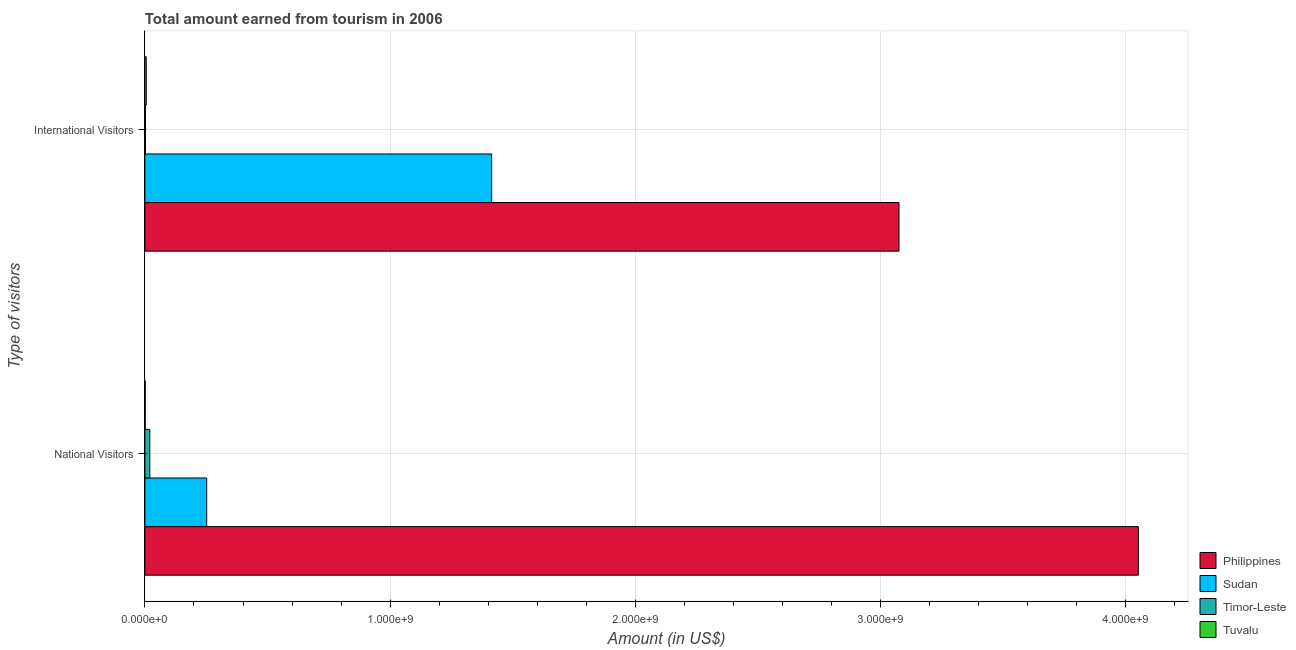How many different coloured bars are there?
Keep it short and to the point. 4. How many groups of bars are there?
Give a very brief answer. 2. Are the number of bars on each tick of the Y-axis equal?
Your answer should be compact. Yes. How many bars are there on the 2nd tick from the top?
Provide a short and direct response. 4. How many bars are there on the 1st tick from the bottom?
Offer a terse response. 4. What is the label of the 2nd group of bars from the top?
Your answer should be very brief. National Visitors. What is the amount earned from international visitors in Timor-Leste?
Give a very brief answer. 2.30e+06. Across all countries, what is the maximum amount earned from international visitors?
Provide a short and direct response. 3.08e+09. Across all countries, what is the minimum amount earned from national visitors?
Your response must be concise. 1.18e+06. In which country was the amount earned from international visitors minimum?
Give a very brief answer. Timor-Leste. What is the total amount earned from national visitors in the graph?
Provide a short and direct response. 4.32e+09. What is the difference between the amount earned from national visitors in Timor-Leste and that in Tuvalu?
Offer a terse response. 1.88e+07. What is the difference between the amount earned from national visitors in Timor-Leste and the amount earned from international visitors in Philippines?
Your answer should be compact. -3.06e+09. What is the average amount earned from international visitors per country?
Provide a short and direct response. 1.12e+09. What is the difference between the amount earned from international visitors and amount earned from national visitors in Tuvalu?
Offer a very short reply. 4.25e+06. What is the ratio of the amount earned from international visitors in Timor-Leste to that in Tuvalu?
Ensure brevity in your answer.  0.42. In how many countries, is the amount earned from international visitors greater than the average amount earned from international visitors taken over all countries?
Offer a very short reply. 2. What does the 4th bar from the top in National Visitors represents?
Provide a short and direct response. Philippines. What does the 2nd bar from the bottom in National Visitors represents?
Offer a terse response. Sudan. How many bars are there?
Keep it short and to the point. 8. How many countries are there in the graph?
Provide a short and direct response. 4. Are the values on the major ticks of X-axis written in scientific E-notation?
Ensure brevity in your answer.  Yes. Does the graph contain grids?
Ensure brevity in your answer.  Yes. Where does the legend appear in the graph?
Your response must be concise. Bottom right. What is the title of the graph?
Keep it short and to the point. Total amount earned from tourism in 2006. Does "Algeria" appear as one of the legend labels in the graph?
Offer a very short reply. No. What is the label or title of the X-axis?
Offer a very short reply. Amount (in US$). What is the label or title of the Y-axis?
Your answer should be compact. Type of visitors. What is the Amount (in US$) in Philippines in National Visitors?
Your answer should be very brief. 4.05e+09. What is the Amount (in US$) in Sudan in National Visitors?
Your answer should be compact. 2.52e+08. What is the Amount (in US$) in Tuvalu in National Visitors?
Offer a terse response. 1.18e+06. What is the Amount (in US$) in Philippines in International Visitors?
Offer a terse response. 3.08e+09. What is the Amount (in US$) of Sudan in International Visitors?
Make the answer very short. 1.41e+09. What is the Amount (in US$) in Timor-Leste in International Visitors?
Your answer should be very brief. 2.30e+06. What is the Amount (in US$) in Tuvalu in International Visitors?
Provide a succinct answer. 5.43e+06. Across all Type of visitors, what is the maximum Amount (in US$) of Philippines?
Give a very brief answer. 4.05e+09. Across all Type of visitors, what is the maximum Amount (in US$) in Sudan?
Offer a very short reply. 1.41e+09. Across all Type of visitors, what is the maximum Amount (in US$) of Timor-Leste?
Keep it short and to the point. 2.00e+07. Across all Type of visitors, what is the maximum Amount (in US$) of Tuvalu?
Ensure brevity in your answer.  5.43e+06. Across all Type of visitors, what is the minimum Amount (in US$) of Philippines?
Provide a succinct answer. 3.08e+09. Across all Type of visitors, what is the minimum Amount (in US$) of Sudan?
Your answer should be compact. 2.52e+08. Across all Type of visitors, what is the minimum Amount (in US$) in Timor-Leste?
Keep it short and to the point. 2.30e+06. Across all Type of visitors, what is the minimum Amount (in US$) of Tuvalu?
Keep it short and to the point. 1.18e+06. What is the total Amount (in US$) in Philippines in the graph?
Offer a terse response. 7.13e+09. What is the total Amount (in US$) of Sudan in the graph?
Offer a very short reply. 1.67e+09. What is the total Amount (in US$) in Timor-Leste in the graph?
Your answer should be compact. 2.23e+07. What is the total Amount (in US$) of Tuvalu in the graph?
Give a very brief answer. 6.61e+06. What is the difference between the Amount (in US$) of Philippines in National Visitors and that in International Visitors?
Ensure brevity in your answer.  9.76e+08. What is the difference between the Amount (in US$) in Sudan in National Visitors and that in International Visitors?
Make the answer very short. -1.16e+09. What is the difference between the Amount (in US$) of Timor-Leste in National Visitors and that in International Visitors?
Make the answer very short. 1.77e+07. What is the difference between the Amount (in US$) in Tuvalu in National Visitors and that in International Visitors?
Provide a short and direct response. -4.25e+06. What is the difference between the Amount (in US$) in Philippines in National Visitors and the Amount (in US$) in Sudan in International Visitors?
Your answer should be compact. 2.64e+09. What is the difference between the Amount (in US$) of Philippines in National Visitors and the Amount (in US$) of Timor-Leste in International Visitors?
Provide a short and direct response. 4.05e+09. What is the difference between the Amount (in US$) in Philippines in National Visitors and the Amount (in US$) in Tuvalu in International Visitors?
Make the answer very short. 4.05e+09. What is the difference between the Amount (in US$) in Sudan in National Visitors and the Amount (in US$) in Timor-Leste in International Visitors?
Offer a terse response. 2.50e+08. What is the difference between the Amount (in US$) in Sudan in National Visitors and the Amount (in US$) in Tuvalu in International Visitors?
Your answer should be compact. 2.47e+08. What is the difference between the Amount (in US$) in Timor-Leste in National Visitors and the Amount (in US$) in Tuvalu in International Visitors?
Provide a short and direct response. 1.46e+07. What is the average Amount (in US$) in Philippines per Type of visitors?
Provide a succinct answer. 3.56e+09. What is the average Amount (in US$) of Sudan per Type of visitors?
Your answer should be very brief. 8.33e+08. What is the average Amount (in US$) in Timor-Leste per Type of visitors?
Offer a very short reply. 1.12e+07. What is the average Amount (in US$) in Tuvalu per Type of visitors?
Your response must be concise. 3.30e+06. What is the difference between the Amount (in US$) in Philippines and Amount (in US$) in Sudan in National Visitors?
Ensure brevity in your answer.  3.80e+09. What is the difference between the Amount (in US$) in Philippines and Amount (in US$) in Timor-Leste in National Visitors?
Ensure brevity in your answer.  4.03e+09. What is the difference between the Amount (in US$) in Philippines and Amount (in US$) in Tuvalu in National Visitors?
Make the answer very short. 4.05e+09. What is the difference between the Amount (in US$) in Sudan and Amount (in US$) in Timor-Leste in National Visitors?
Give a very brief answer. 2.32e+08. What is the difference between the Amount (in US$) in Sudan and Amount (in US$) in Tuvalu in National Visitors?
Your answer should be very brief. 2.51e+08. What is the difference between the Amount (in US$) in Timor-Leste and Amount (in US$) in Tuvalu in National Visitors?
Offer a terse response. 1.88e+07. What is the difference between the Amount (in US$) in Philippines and Amount (in US$) in Sudan in International Visitors?
Your response must be concise. 1.66e+09. What is the difference between the Amount (in US$) in Philippines and Amount (in US$) in Timor-Leste in International Visitors?
Your answer should be very brief. 3.07e+09. What is the difference between the Amount (in US$) of Philippines and Amount (in US$) of Tuvalu in International Visitors?
Provide a succinct answer. 3.07e+09. What is the difference between the Amount (in US$) in Sudan and Amount (in US$) in Timor-Leste in International Visitors?
Your response must be concise. 1.41e+09. What is the difference between the Amount (in US$) of Sudan and Amount (in US$) of Tuvalu in International Visitors?
Keep it short and to the point. 1.41e+09. What is the difference between the Amount (in US$) of Timor-Leste and Amount (in US$) of Tuvalu in International Visitors?
Ensure brevity in your answer.  -3.13e+06. What is the ratio of the Amount (in US$) of Philippines in National Visitors to that in International Visitors?
Provide a short and direct response. 1.32. What is the ratio of the Amount (in US$) in Sudan in National Visitors to that in International Visitors?
Offer a very short reply. 0.18. What is the ratio of the Amount (in US$) of Timor-Leste in National Visitors to that in International Visitors?
Provide a short and direct response. 8.7. What is the ratio of the Amount (in US$) of Tuvalu in National Visitors to that in International Visitors?
Provide a short and direct response. 0.22. What is the difference between the highest and the second highest Amount (in US$) in Philippines?
Ensure brevity in your answer.  9.76e+08. What is the difference between the highest and the second highest Amount (in US$) of Sudan?
Make the answer very short. 1.16e+09. What is the difference between the highest and the second highest Amount (in US$) of Timor-Leste?
Keep it short and to the point. 1.77e+07. What is the difference between the highest and the second highest Amount (in US$) of Tuvalu?
Provide a short and direct response. 4.25e+06. What is the difference between the highest and the lowest Amount (in US$) of Philippines?
Offer a very short reply. 9.76e+08. What is the difference between the highest and the lowest Amount (in US$) in Sudan?
Provide a short and direct response. 1.16e+09. What is the difference between the highest and the lowest Amount (in US$) of Timor-Leste?
Your answer should be compact. 1.77e+07. What is the difference between the highest and the lowest Amount (in US$) in Tuvalu?
Make the answer very short. 4.25e+06. 